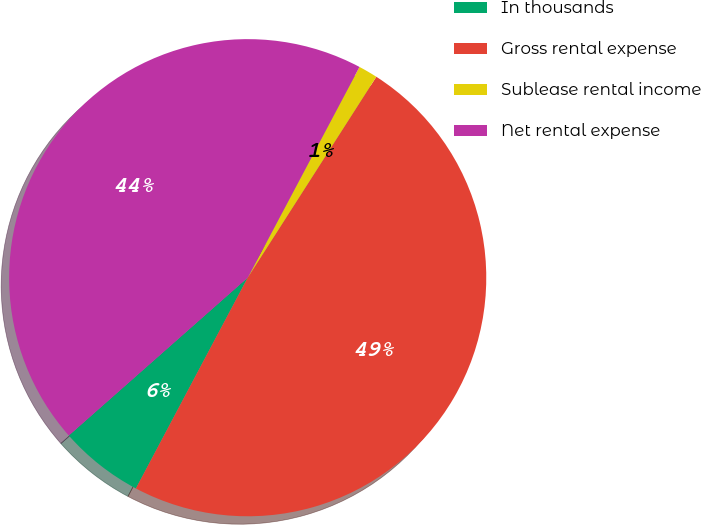Convert chart to OTSL. <chart><loc_0><loc_0><loc_500><loc_500><pie_chart><fcel>In thousands<fcel>Gross rental expense<fcel>Sublease rental income<fcel>Net rental expense<nl><fcel>5.73%<fcel>48.7%<fcel>1.3%<fcel>44.27%<nl></chart> 